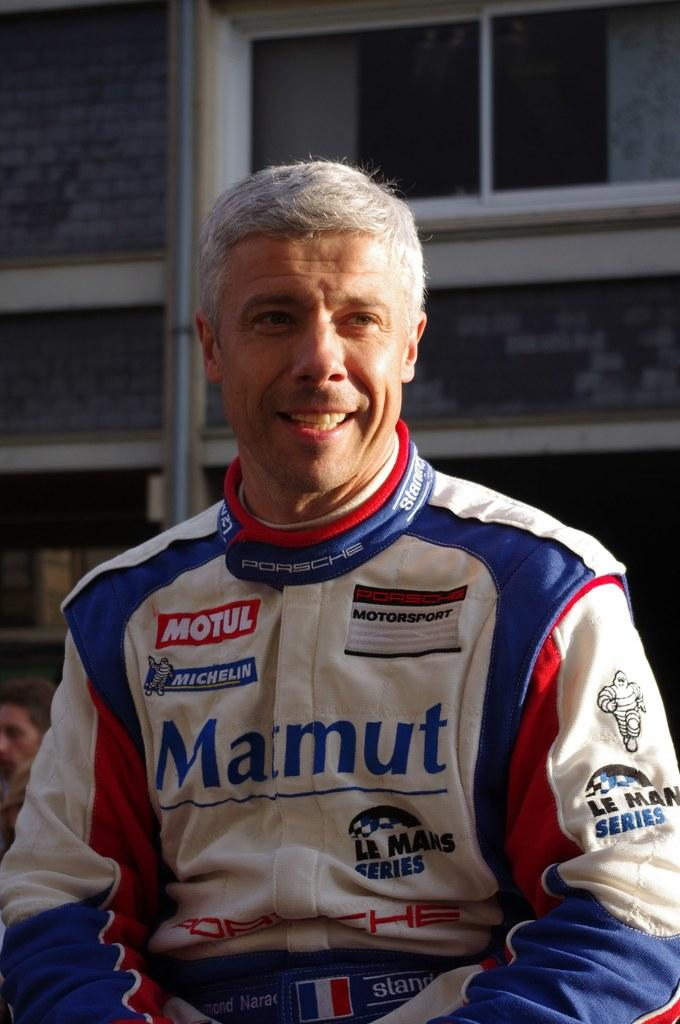Provide a one-sentence caption for the provided image. A race car driver with grey hair and a Marmut jacket is smiling. 